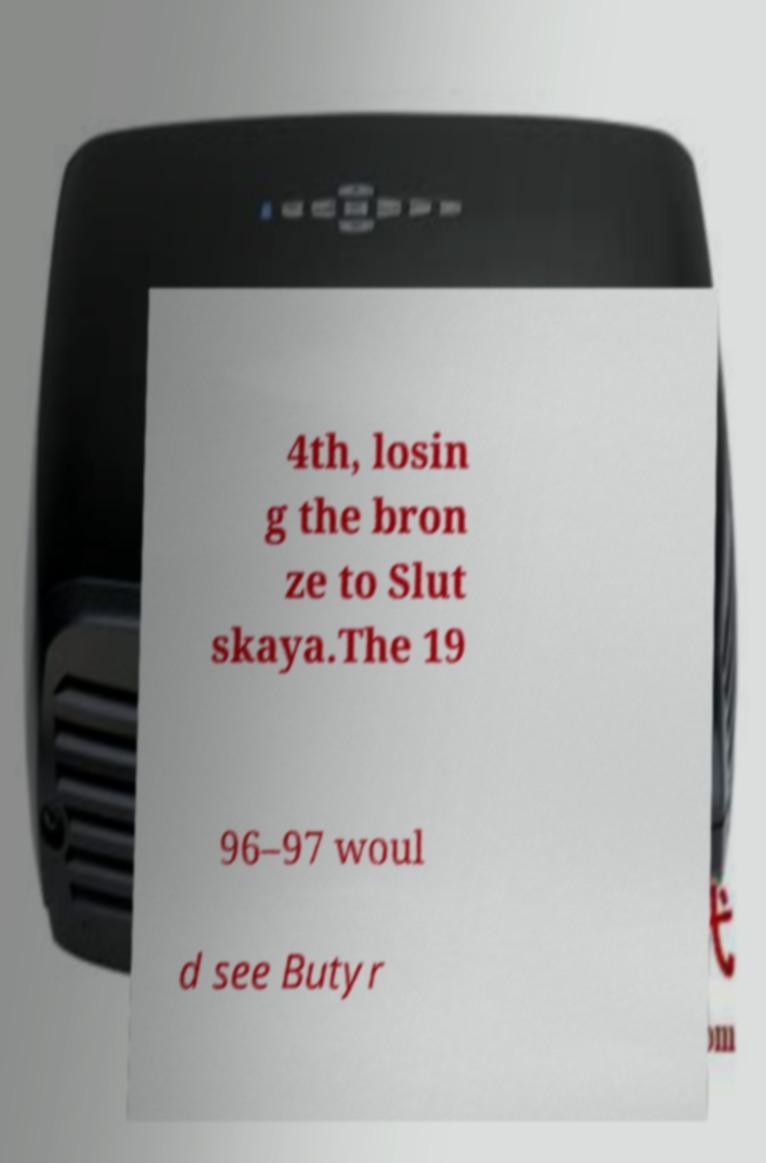For documentation purposes, I need the text within this image transcribed. Could you provide that? 4th, losin g the bron ze to Slut skaya.The 19 96–97 woul d see Butyr 